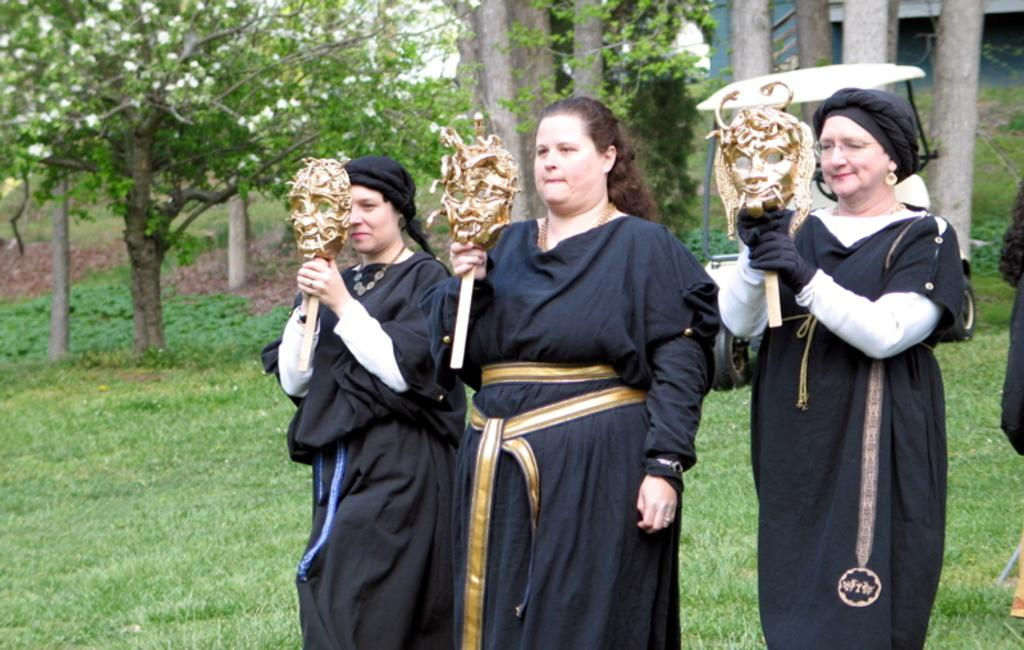Who is present in the image? There are women in the image. What are the women doing in the image? The women are standing in the image. What are the women holding in their hands? The women are holding a mask stick in their hands. How many elbows can be seen in the image? There is no mention of elbows in the provided facts, so it is impossible to determine the number of elbows visible in the image. 